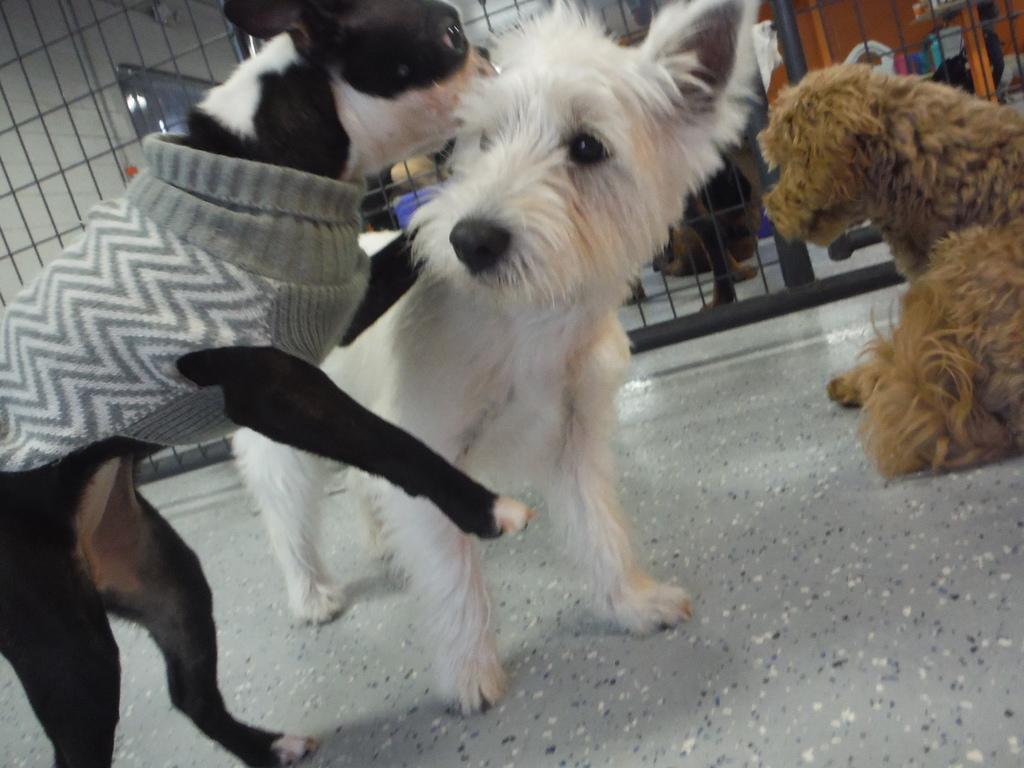Could you give a brief overview of what you see in this image? Here I can see three dogs on the floor. In the background there is a net. Behind there are few objects. 